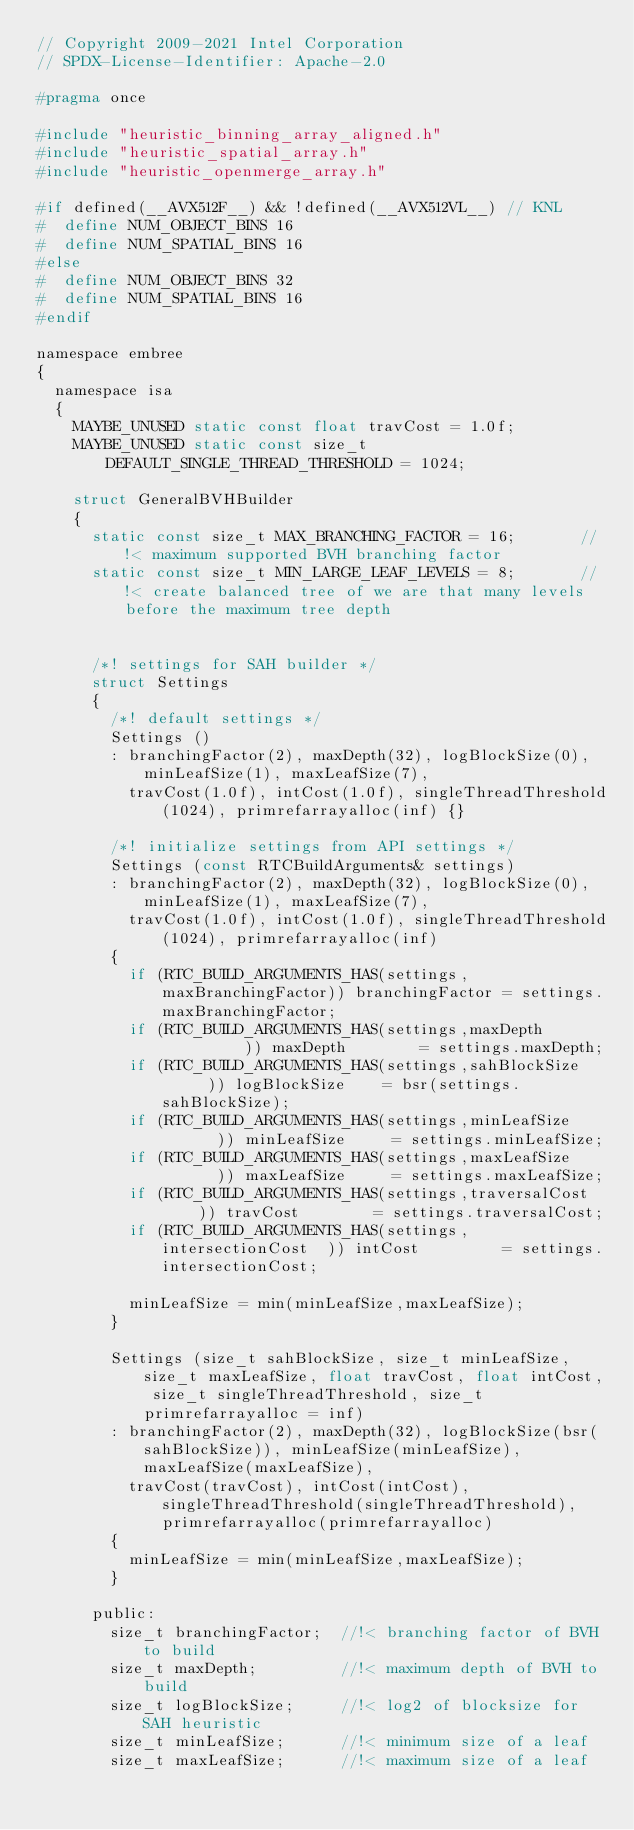<code> <loc_0><loc_0><loc_500><loc_500><_C_>// Copyright 2009-2021 Intel Corporation
// SPDX-License-Identifier: Apache-2.0

#pragma once

#include "heuristic_binning_array_aligned.h"
#include "heuristic_spatial_array.h"
#include "heuristic_openmerge_array.h"

#if defined(__AVX512F__) && !defined(__AVX512VL__) // KNL
#  define NUM_OBJECT_BINS 16
#  define NUM_SPATIAL_BINS 16
#else
#  define NUM_OBJECT_BINS 32
#  define NUM_SPATIAL_BINS 16
#endif

namespace embree
{
  namespace isa
  {
    MAYBE_UNUSED static const float travCost = 1.0f;
    MAYBE_UNUSED static const size_t DEFAULT_SINGLE_THREAD_THRESHOLD = 1024;

    struct GeneralBVHBuilder
    {
      static const size_t MAX_BRANCHING_FACTOR = 16;       //!< maximum supported BVH branching factor      
      static const size_t MIN_LARGE_LEAF_LEVELS = 8;       //!< create balanced tree of we are that many levels before the maximum tree depth
      

      /*! settings for SAH builder */
      struct Settings
      {
        /*! default settings */
        Settings ()
        : branchingFactor(2), maxDepth(32), logBlockSize(0), minLeafSize(1), maxLeafSize(7),
          travCost(1.0f), intCost(1.0f), singleThreadThreshold(1024), primrefarrayalloc(inf) {}

        /*! initialize settings from API settings */
        Settings (const RTCBuildArguments& settings)
        : branchingFactor(2), maxDepth(32), logBlockSize(0), minLeafSize(1), maxLeafSize(7),
          travCost(1.0f), intCost(1.0f), singleThreadThreshold(1024), primrefarrayalloc(inf)
        {
          if (RTC_BUILD_ARGUMENTS_HAS(settings,maxBranchingFactor)) branchingFactor = settings.maxBranchingFactor;
          if (RTC_BUILD_ARGUMENTS_HAS(settings,maxDepth          )) maxDepth        = settings.maxDepth;
          if (RTC_BUILD_ARGUMENTS_HAS(settings,sahBlockSize      )) logBlockSize    = bsr(settings.sahBlockSize);
          if (RTC_BUILD_ARGUMENTS_HAS(settings,minLeafSize       )) minLeafSize     = settings.minLeafSize;
          if (RTC_BUILD_ARGUMENTS_HAS(settings,maxLeafSize       )) maxLeafSize     = settings.maxLeafSize;
          if (RTC_BUILD_ARGUMENTS_HAS(settings,traversalCost     )) travCost        = settings.traversalCost;
          if (RTC_BUILD_ARGUMENTS_HAS(settings,intersectionCost  )) intCost         = settings.intersectionCost;

          minLeafSize = min(minLeafSize,maxLeafSize);
        }

        Settings (size_t sahBlockSize, size_t minLeafSize, size_t maxLeafSize, float travCost, float intCost, size_t singleThreadThreshold, size_t primrefarrayalloc = inf)
        : branchingFactor(2), maxDepth(32), logBlockSize(bsr(sahBlockSize)), minLeafSize(minLeafSize), maxLeafSize(maxLeafSize),
          travCost(travCost), intCost(intCost), singleThreadThreshold(singleThreadThreshold), primrefarrayalloc(primrefarrayalloc)
        {
          minLeafSize = min(minLeafSize,maxLeafSize);
        }

      public:
        size_t branchingFactor;  //!< branching factor of BVH to build
        size_t maxDepth;         //!< maximum depth of BVH to build
        size_t logBlockSize;     //!< log2 of blocksize for SAH heuristic
        size_t minLeafSize;      //!< minimum size of a leaf
        size_t maxLeafSize;      //!< maximum size of a leaf</code> 